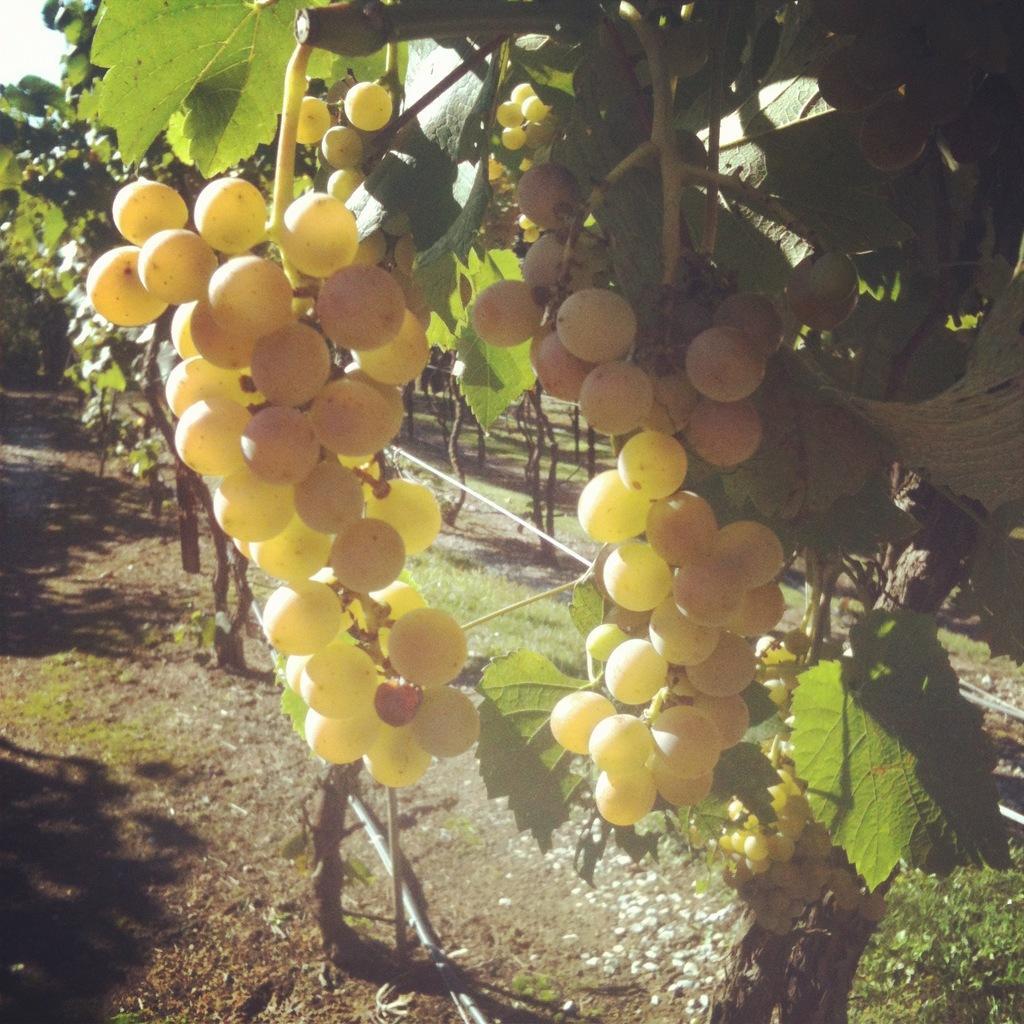How would you summarize this image in a sentence or two? In this image we can see a vineyard, pipelines and sky. 